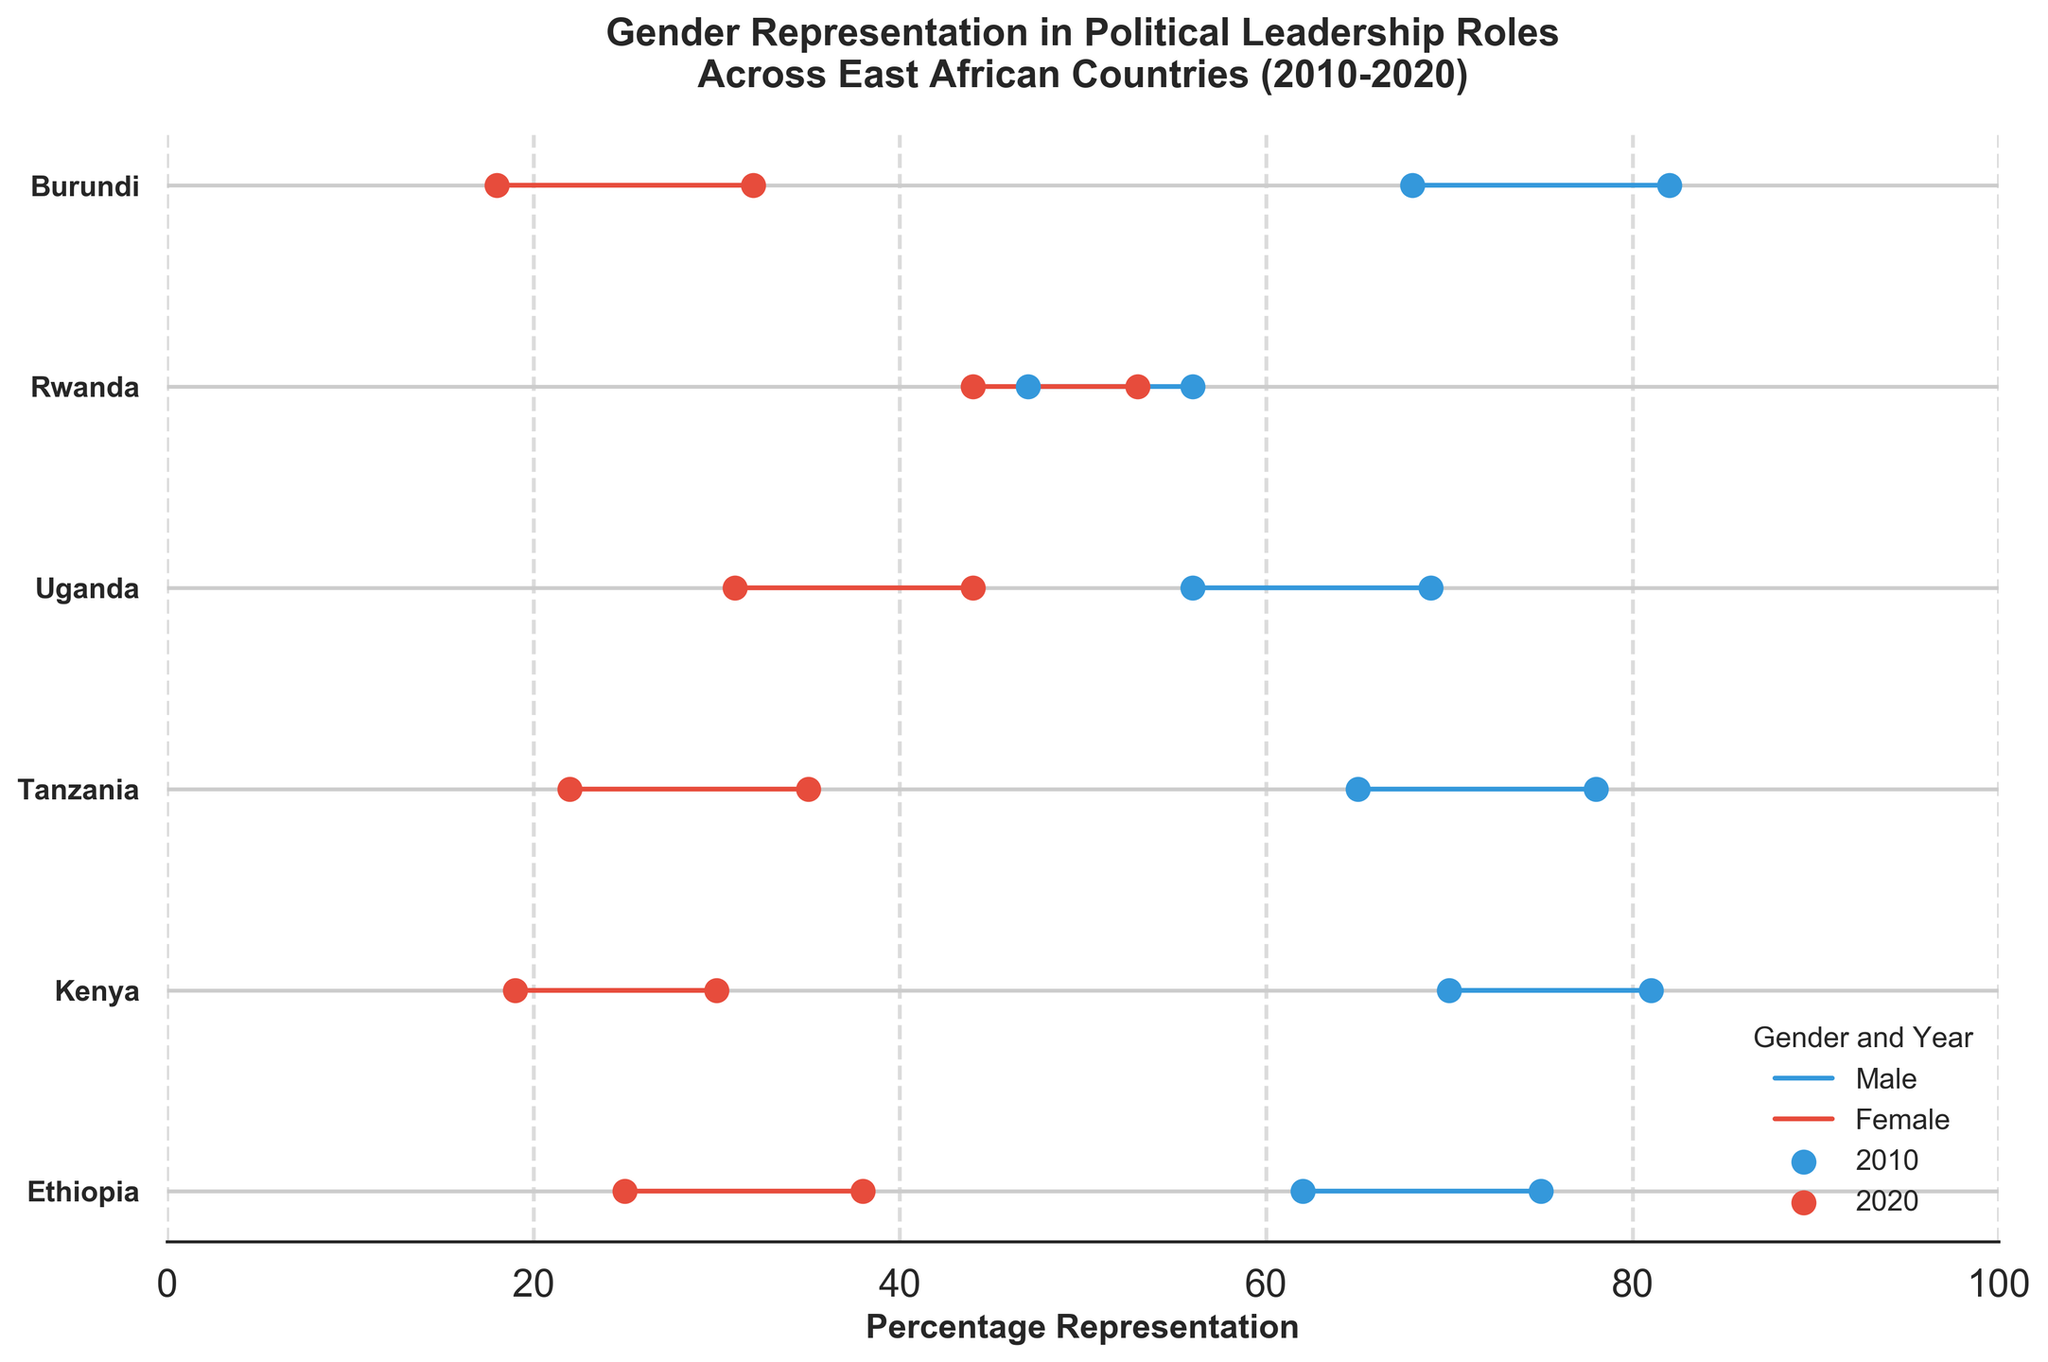Which country had the highest female representation in political leadership in 2020? Observe the red markers for 2020 female representation in the figure. Rwanda has the highest female representation reaching 53% in 2020.
Answer: Rwanda How did male representation in political leadership in Ethiopia change between 2010 and 2020? Look at the blue lines and markers for Ethiopia. The male representation dropped from 75% in 2010 to 62% in 2020.
Answer: Decreased by 13% Which country had a decrease in female representation from 2010 to 2020? Compare the red markers for 2010 and 2020 across all countries. No country shows a decrease in female representation; all show an increase.
Answer: None What was the change in female representation for Uganda from 2010 to 2020? Look at Uganda's red markers. The female representation increased from 31% in 2010 to 44% in 2020. Calculation: 44% - 31% = 13%.
Answer: Increased by 13% Which country had the smallest gender gap in political leadership in 2020? Calculate the difference between male and female markers for 2020. Rwanda had the smallest gap with male at 47% and female at 53%, thus a gap of 6%.
Answer: Rwanda How did female representation in Kenya change between 2010 and 2020? Observe the red markers for Kenya. The female representation increased from 19% in 2010 to 30% in 2020.
Answer: Increased by 11% Compare the male representation in Burundi and Tanzania in 2020. Which country had a higher male representation? Compare the blue markers for Burundi and Tanzania in 2020. Burundi had 68% while Tanzania had 65%.
Answer: Burundi What is the average female representation in Uganda for the years 2010 and 2020? Calculate the average of the red markers for Uganda's 2010 and 2020 data. (31% + 44%) / 2 = 37.5%
Answer: 37.5% Which country's male representation saw the greatest decrease from 2010 to 2020? Compare the difference in male representation markers from 2010 to 2020 across all countries. Burundi had the greatest decrease from 82% to 68%, a reduction of 14%.
Answer: Burundi What is the median female representation in 2020 among the listed countries? List female representation values for 2020 from all countries: 38, 30, 35, 44, 53, 32. Arrange in ascending order: 30, 32, 35, 38, 44, 53. The median is the average of the middle two values, (35+38)/2 = 36.5
Answer: 36.5 